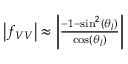<formula> <loc_0><loc_0><loc_500><loc_500>\begin{array} { r } { \left | f _ { V V } \right | \approx \left | \frac { - 1 - \sin ^ { 2 } ( \theta _ { l } ) } { \cos ( \theta _ { l } ) } \right | } \end{array}</formula> 